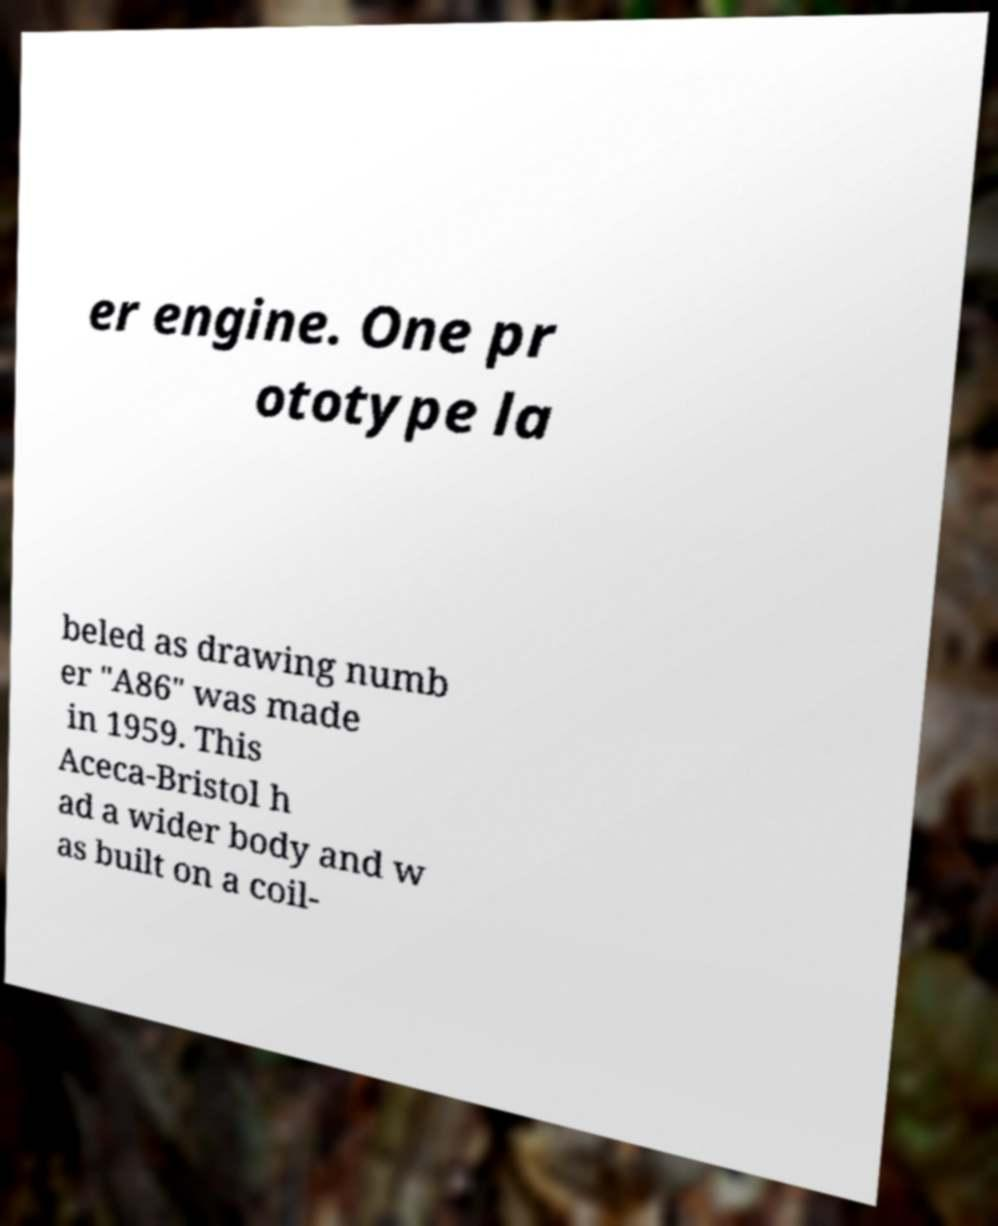Please identify and transcribe the text found in this image. er engine. One pr ototype la beled as drawing numb er "A86" was made in 1959. This Aceca-Bristol h ad a wider body and w as built on a coil- 